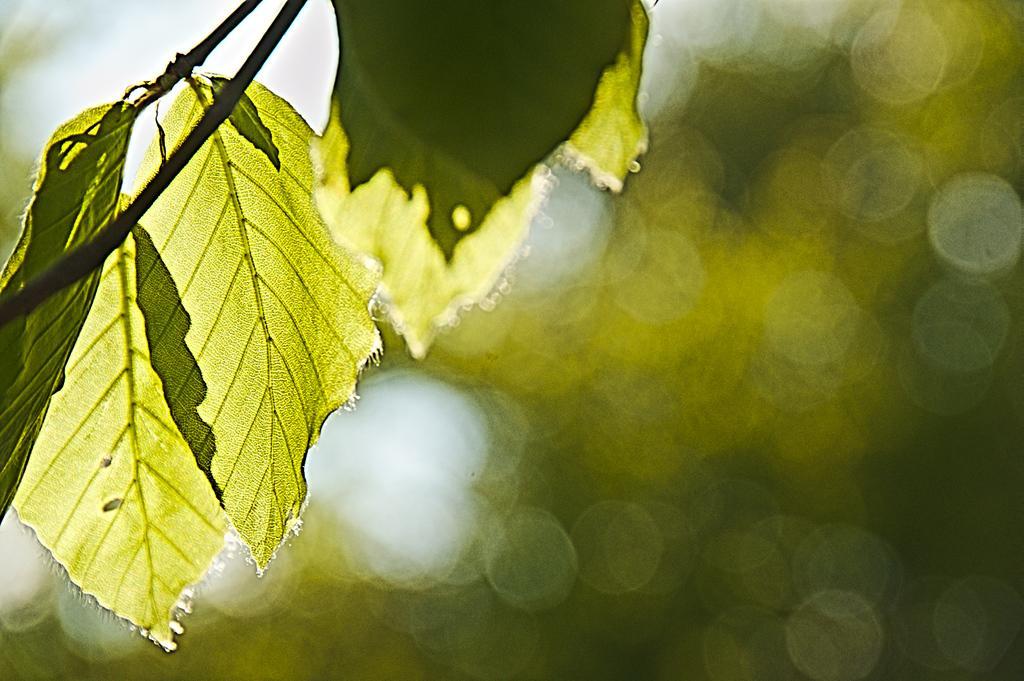Could you give a brief overview of what you see in this image? In this image we can see leaves. 